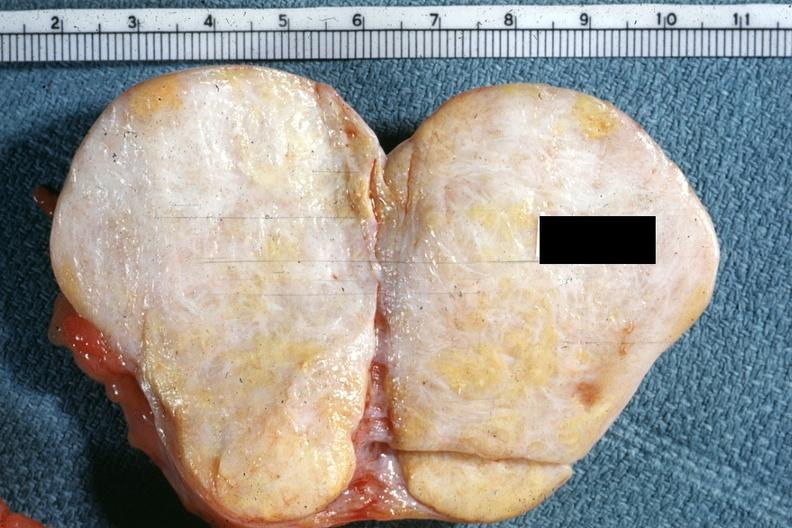what is present?
Answer the question using a single word or phrase. Female reproductive 